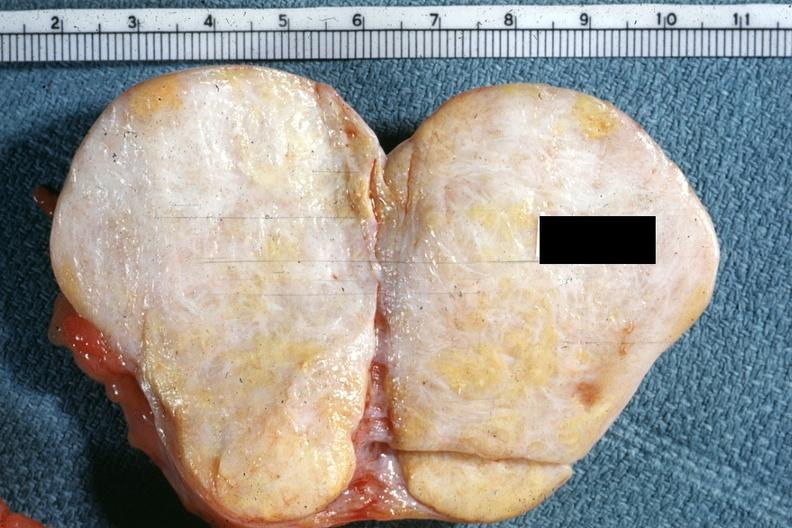what is present?
Answer the question using a single word or phrase. Female reproductive 